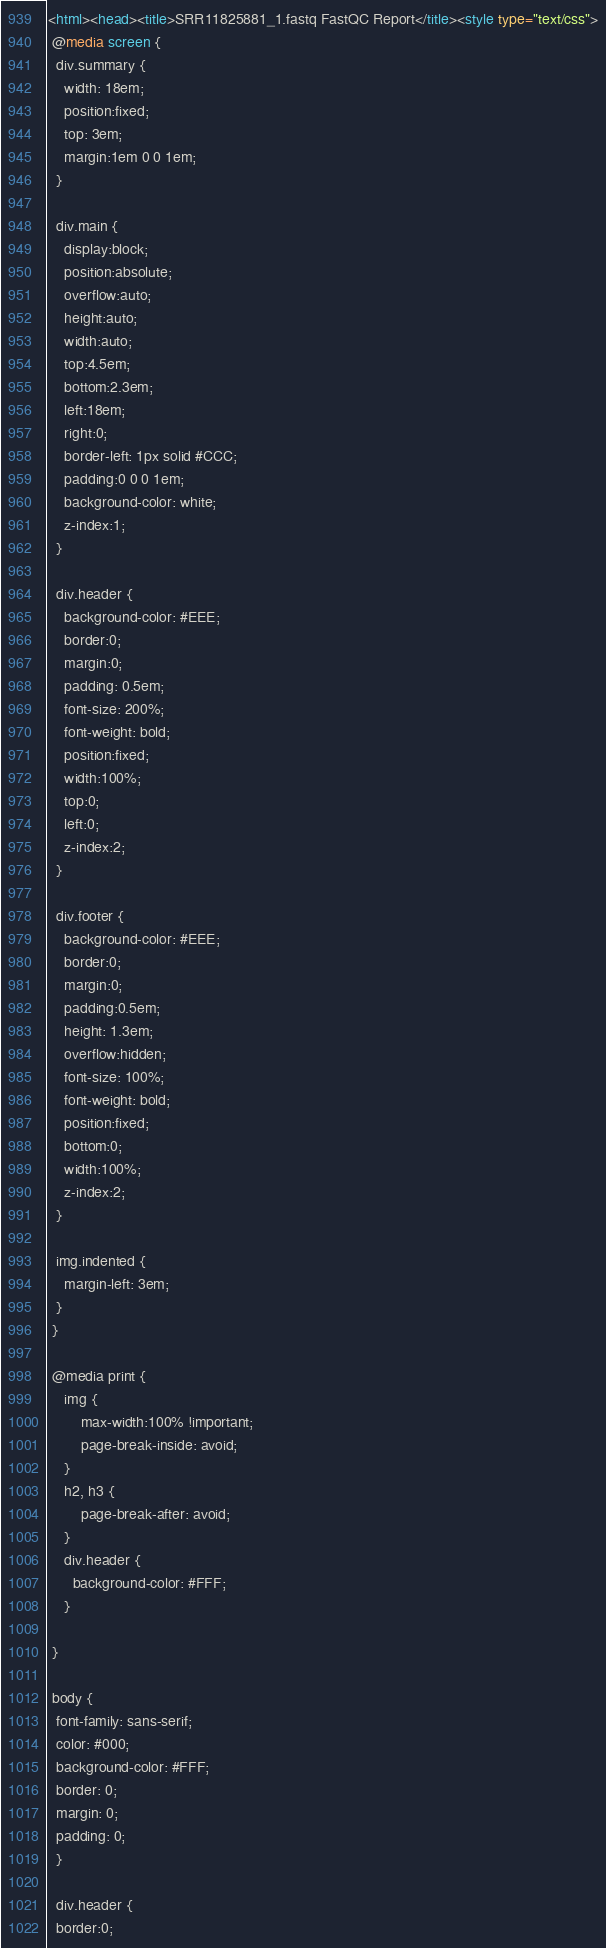<code> <loc_0><loc_0><loc_500><loc_500><_HTML_><html><head><title>SRR11825881_1.fastq FastQC Report</title><style type="text/css">
 @media screen {
  div.summary {
    width: 18em;
    position:fixed;
    top: 3em;
    margin:1em 0 0 1em;
  }
  
  div.main {
    display:block;
    position:absolute;
    overflow:auto;
    height:auto;
    width:auto;
    top:4.5em;
    bottom:2.3em;
    left:18em;
    right:0;
    border-left: 1px solid #CCC;
    padding:0 0 0 1em;
    background-color: white;
    z-index:1;
  }
  
  div.header {
    background-color: #EEE;
    border:0;
    margin:0;
    padding: 0.5em;
    font-size: 200%;
    font-weight: bold;
    position:fixed;
    width:100%;
    top:0;
    left:0;
    z-index:2;
  }

  div.footer {
    background-color: #EEE;
    border:0;
    margin:0;
	padding:0.5em;
    height: 1.3em;
	overflow:hidden;
    font-size: 100%;
    font-weight: bold;
    position:fixed;
    bottom:0;
    width:100%;
    z-index:2;
  }
  
  img.indented {
    margin-left: 3em;
  }
 }
 
 @media print {
	img {
		max-width:100% !important;
		page-break-inside: avoid;
	}
	h2, h3 {
		page-break-after: avoid;
	}
	div.header {
      background-color: #FFF;
    }
	
 }
 
 body {    
  font-family: sans-serif;   
  color: #000;   
  background-color: #FFF;
  border: 0;
  margin: 0;
  padding: 0;
  }
  
  div.header {
  border:0;</code> 